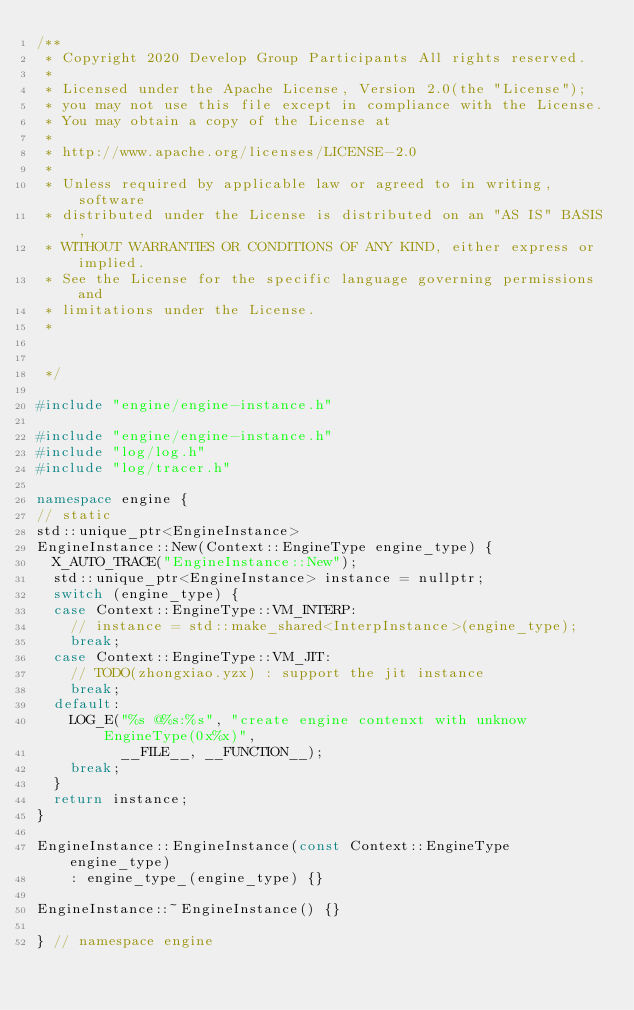Convert code to text. <code><loc_0><loc_0><loc_500><loc_500><_C++_>/**
 * Copyright 2020 Develop Group Participants All rights reserved.
 *
 * Licensed under the Apache License, Version 2.0(the "License");
 * you may not use this file except in compliance with the License.
 * You may obtain a copy of the License at
 *
 * http://www.apache.org/licenses/LICENSE-2.0
 *
 * Unless required by applicable law or agreed to in writing, software
 * distributed under the License is distributed on an "AS IS" BASIS,
 * WITHOUT WARRANTIES OR CONDITIONS OF ANY KIND, either express or implied.
 * See the License for the specific language governing permissions and
 * limitations under the License.
 *


 */

#include "engine/engine-instance.h"

#include "engine/engine-instance.h"
#include "log/log.h"
#include "log/tracer.h"

namespace engine {
// static
std::unique_ptr<EngineInstance>
EngineInstance::New(Context::EngineType engine_type) {
  X_AUTO_TRACE("EngineInstance::New");
  std::unique_ptr<EngineInstance> instance = nullptr;
  switch (engine_type) {
  case Context::EngineType::VM_INTERP:
    // instance = std::make_shared<InterpInstance>(engine_type);
    break;
  case Context::EngineType::VM_JIT:
    // TODO(zhongxiao.yzx) : support the jit instance
    break;
  default:
    LOG_E("%s @%s:%s", "create engine contenxt with unknow EngineType(0x%x)",
          __FILE__, __FUNCTION__);
    break;
  }
  return instance;
}

EngineInstance::EngineInstance(const Context::EngineType engine_type)
    : engine_type_(engine_type) {}

EngineInstance::~EngineInstance() {}

} // namespace engine
</code> 